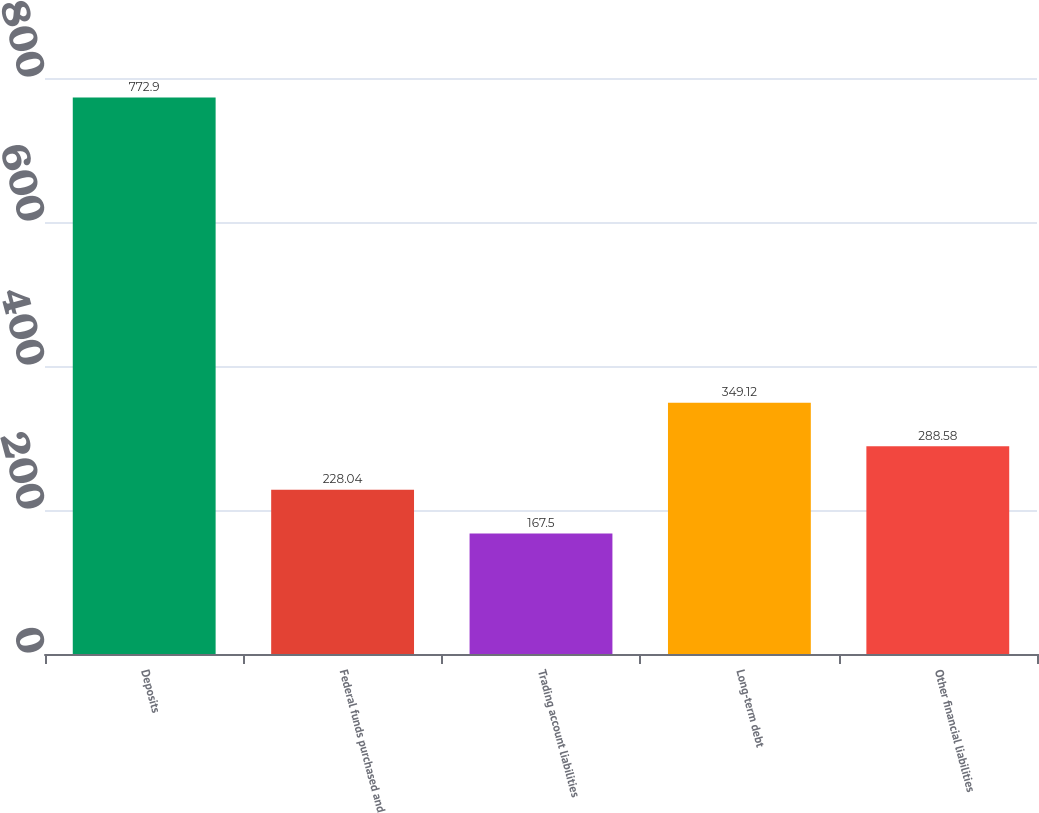Convert chart. <chart><loc_0><loc_0><loc_500><loc_500><bar_chart><fcel>Deposits<fcel>Federal funds purchased and<fcel>Trading account liabilities<fcel>Long-term debt<fcel>Other financial liabilities<nl><fcel>772.9<fcel>228.04<fcel>167.5<fcel>349.12<fcel>288.58<nl></chart> 